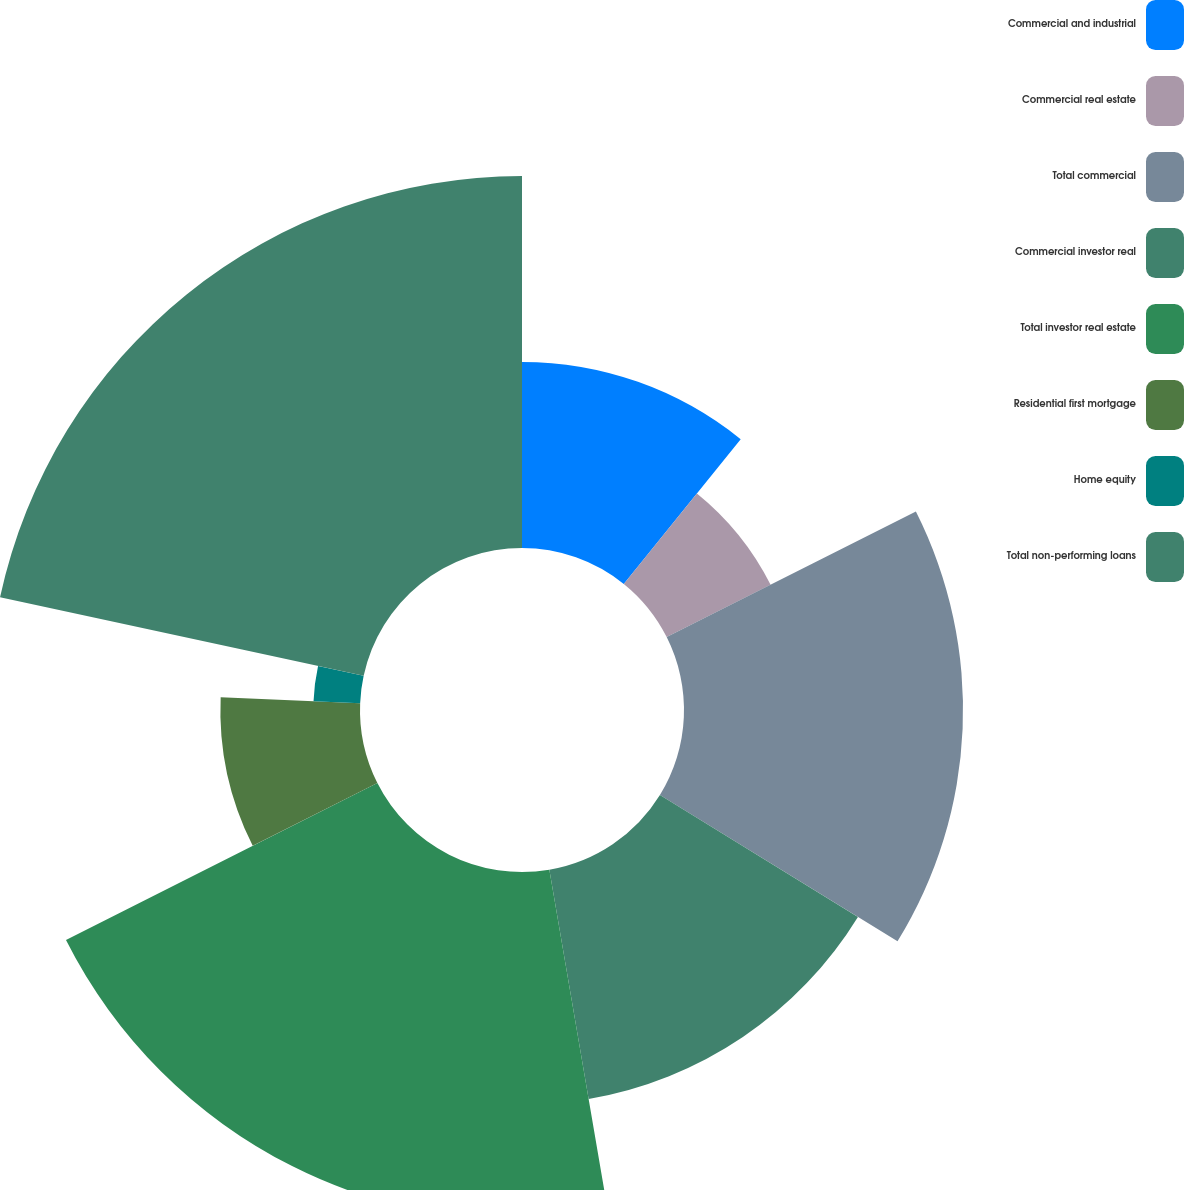<chart> <loc_0><loc_0><loc_500><loc_500><pie_chart><fcel>Commercial and industrial<fcel>Commercial real estate<fcel>Total commercial<fcel>Commercial investor real<fcel>Total investor real estate<fcel>Residential first mortgage<fcel>Home equity<fcel>Total non-performing loans<nl><fcel>10.81%<fcel>6.76%<fcel>16.21%<fcel>13.51%<fcel>20.26%<fcel>8.11%<fcel>2.71%<fcel>21.61%<nl></chart> 